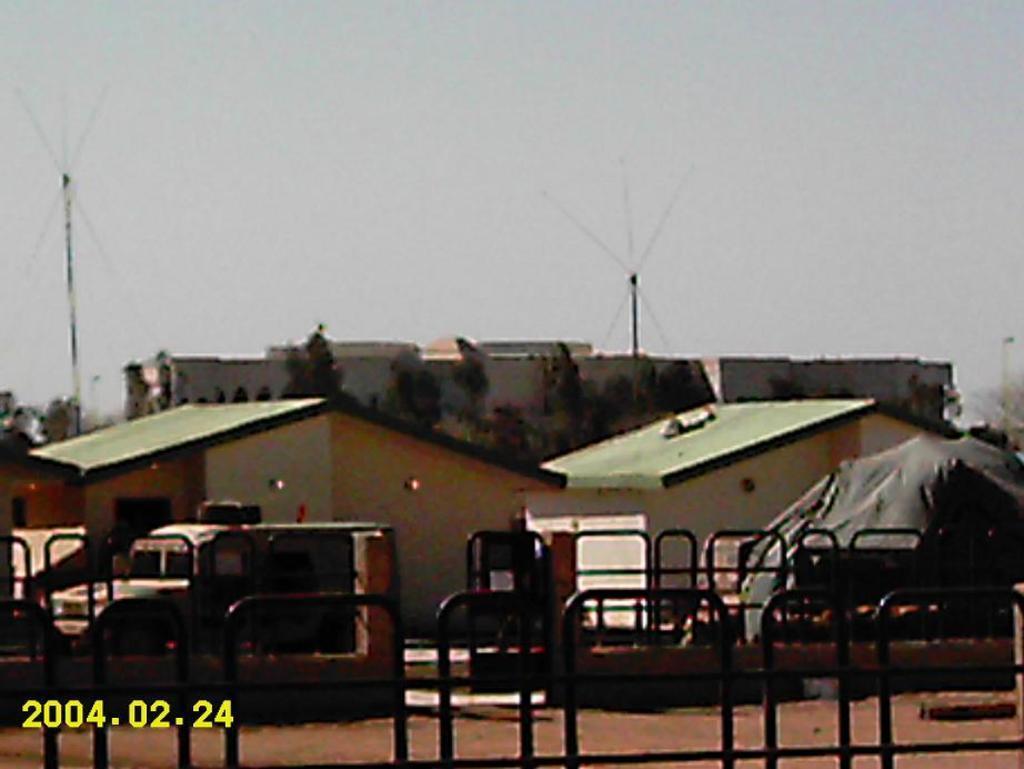In one or two sentences, can you explain what this image depicts? In this image, I can see the buildings, trees and poles. In front of the buildings, I can see a vehicle and iron grilles. At the bottom left side of the image, I can see the watermark. In the background, there is the sky. 